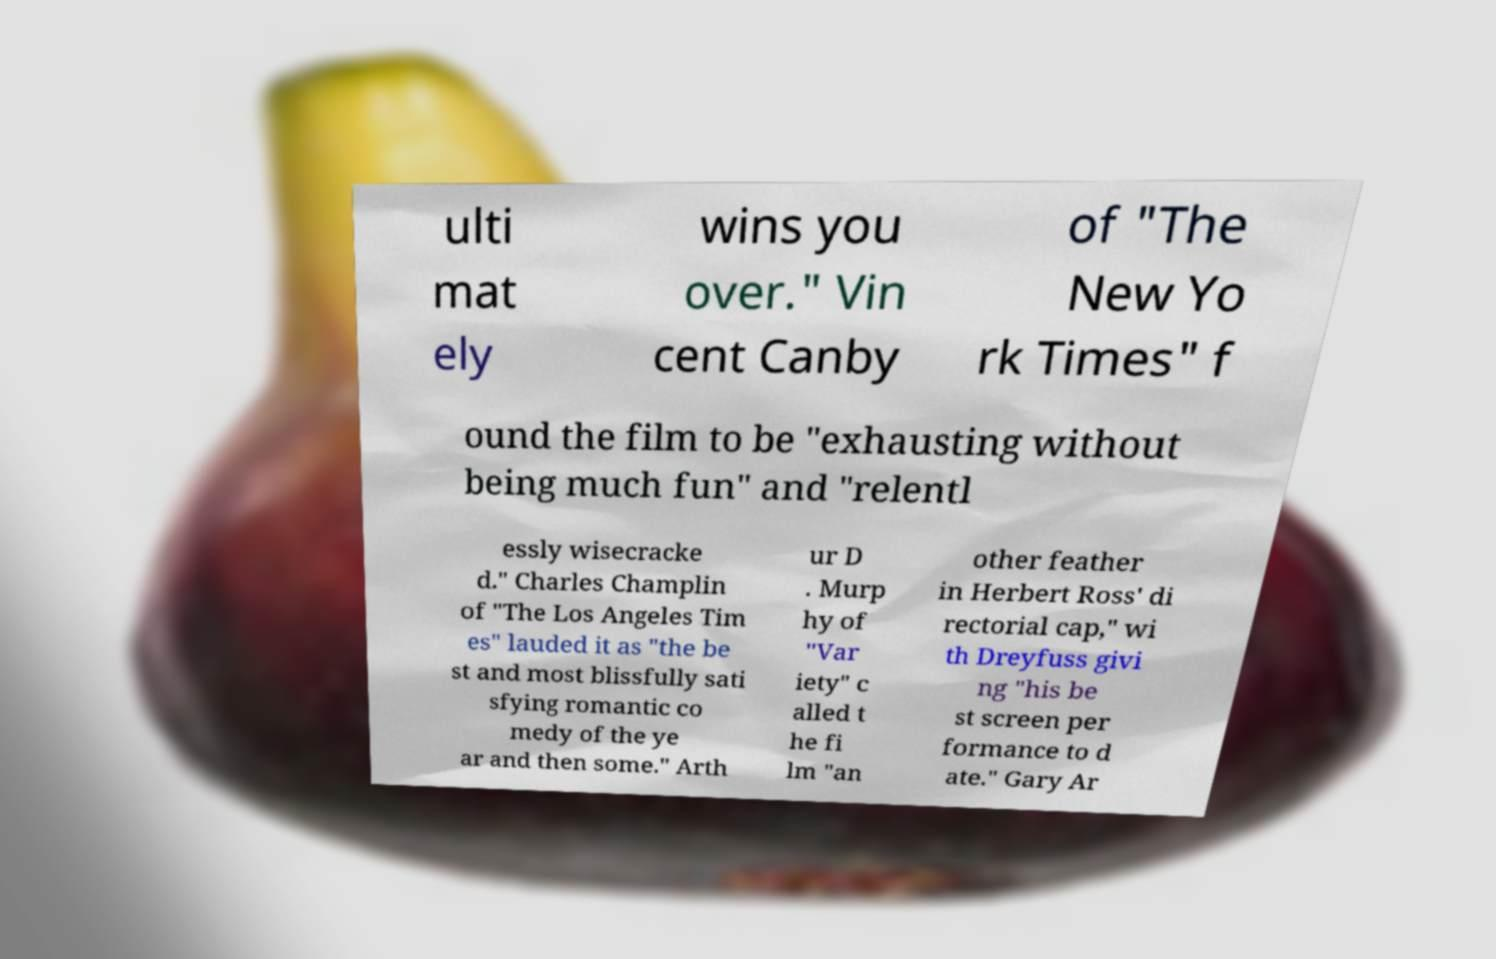Could you assist in decoding the text presented in this image and type it out clearly? ulti mat ely wins you over." Vin cent Canby of "The New Yo rk Times" f ound the film to be "exhausting without being much fun" and "relentl essly wisecracke d." Charles Champlin of "The Los Angeles Tim es" lauded it as "the be st and most blissfully sati sfying romantic co medy of the ye ar and then some." Arth ur D . Murp hy of "Var iety" c alled t he fi lm "an other feather in Herbert Ross' di rectorial cap," wi th Dreyfuss givi ng "his be st screen per formance to d ate." Gary Ar 